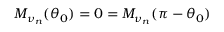<formula> <loc_0><loc_0><loc_500><loc_500>M _ { \nu _ { n } } ( \theta _ { 0 } ) = 0 = M _ { \nu _ { n } } ( \pi - \theta _ { 0 } )</formula> 